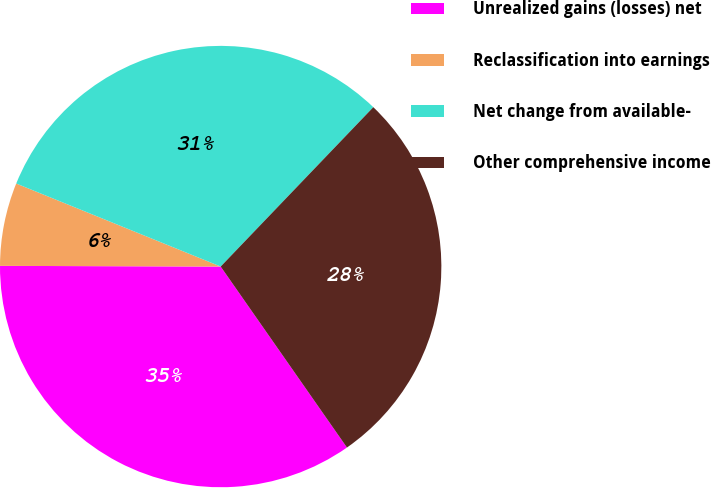Convert chart to OTSL. <chart><loc_0><loc_0><loc_500><loc_500><pie_chart><fcel>Unrealized gains (losses) net<fcel>Reclassification into earnings<fcel>Net change from available-<fcel>Other comprehensive income<nl><fcel>34.75%<fcel>6.09%<fcel>31.02%<fcel>28.15%<nl></chart> 